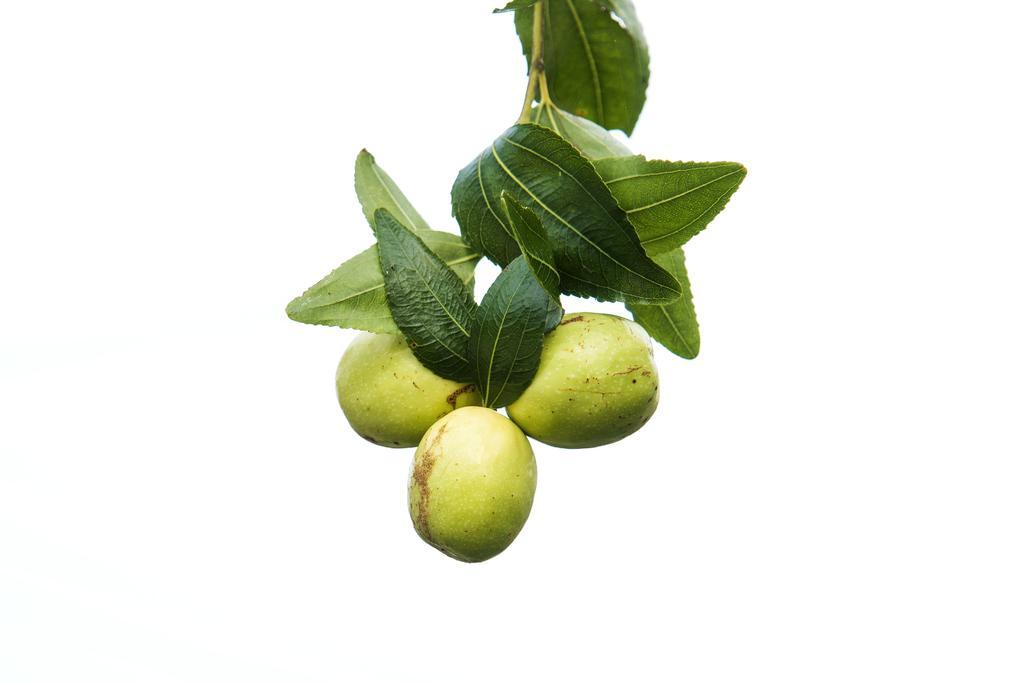Describe this image in one or two sentences. In the center of the image there are fruits and leaves. 